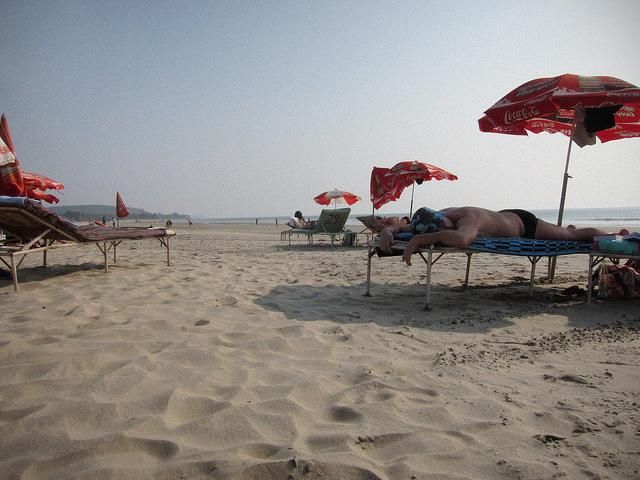The man lying down uses the umbrella for what?

Choices:
A) rain protection
B) signaling
C) shade
D) advertising shade 